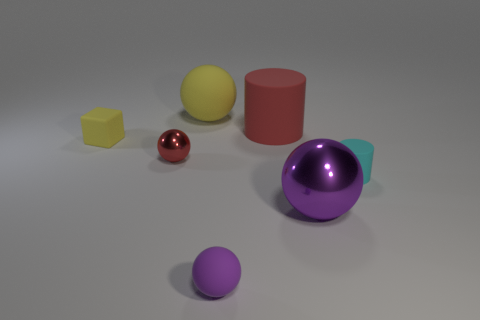Are there any yellow rubber spheres behind the large yellow matte ball?
Ensure brevity in your answer.  No. What is the big cylinder made of?
Offer a terse response. Rubber. Does the matte ball that is left of the purple rubber object have the same color as the tiny rubber block?
Offer a terse response. Yes. Is there anything else that has the same shape as the small yellow object?
Your response must be concise. No. The other large matte thing that is the same shape as the large purple thing is what color?
Ensure brevity in your answer.  Yellow. What material is the tiny object that is in front of the small cyan object?
Your answer should be compact. Rubber. What is the color of the small rubber block?
Offer a terse response. Yellow. Is the size of the ball that is behind the red shiny thing the same as the cyan rubber cylinder?
Make the answer very short. No. What material is the small sphere behind the tiny cyan rubber cylinder that is behind the big ball that is in front of the small matte cylinder?
Provide a short and direct response. Metal. Is the color of the small rubber thing that is on the right side of the big red object the same as the tiny sphere that is to the right of the yellow rubber sphere?
Offer a terse response. No. 